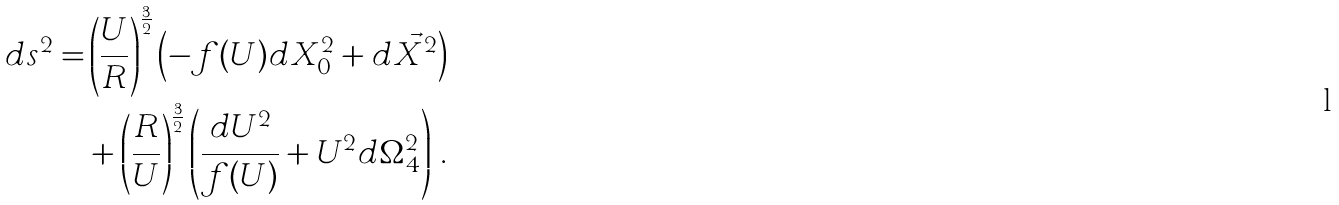Convert formula to latex. <formula><loc_0><loc_0><loc_500><loc_500>d s ^ { 2 } = & \left ( \frac { U } { R } \right ) ^ { \frac { 3 } { 2 } } \left ( - f ( U ) d X _ { 0 } ^ { 2 } + d \vec { X } ^ { 2 } \right ) \\ & + \left ( \frac { R } { U } \right ) ^ { \frac { 3 } { 2 } } \left ( \frac { d U ^ { 2 } } { f ( U ) } + U ^ { 2 } d \Omega _ { 4 } ^ { 2 } \right ) \, .</formula> 